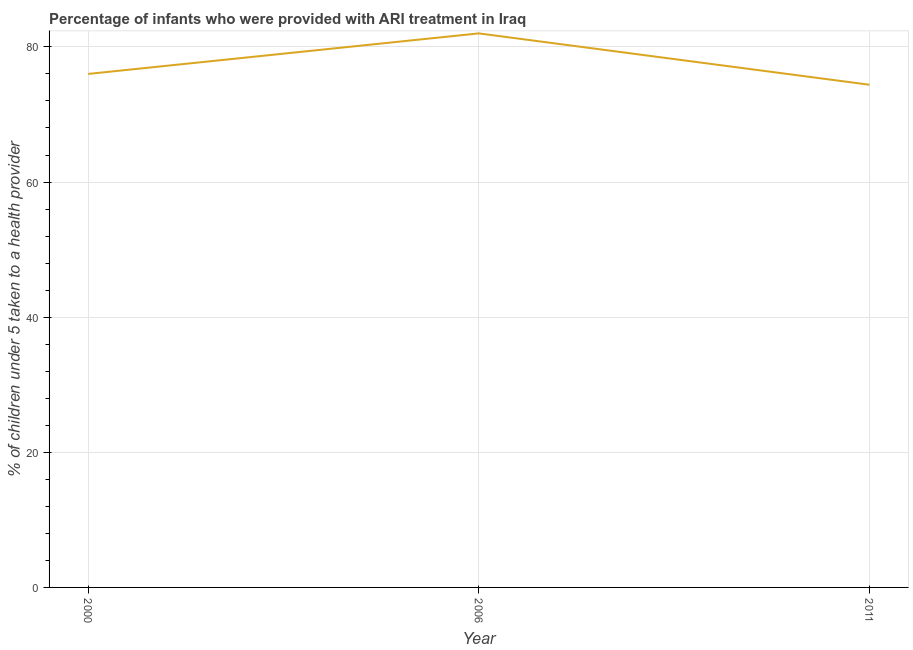What is the percentage of children who were provided with ari treatment in 2000?
Make the answer very short. 76. Across all years, what is the maximum percentage of children who were provided with ari treatment?
Give a very brief answer. 82. Across all years, what is the minimum percentage of children who were provided with ari treatment?
Offer a very short reply. 74.4. In which year was the percentage of children who were provided with ari treatment maximum?
Offer a very short reply. 2006. What is the sum of the percentage of children who were provided with ari treatment?
Keep it short and to the point. 232.4. What is the difference between the percentage of children who were provided with ari treatment in 2006 and 2011?
Offer a very short reply. 7.6. What is the average percentage of children who were provided with ari treatment per year?
Your answer should be compact. 77.47. In how many years, is the percentage of children who were provided with ari treatment greater than 24 %?
Your answer should be compact. 3. What is the ratio of the percentage of children who were provided with ari treatment in 2000 to that in 2011?
Make the answer very short. 1.02. Is the percentage of children who were provided with ari treatment in 2006 less than that in 2011?
Provide a short and direct response. No. Is the difference between the percentage of children who were provided with ari treatment in 2000 and 2006 greater than the difference between any two years?
Your answer should be compact. No. What is the difference between the highest and the lowest percentage of children who were provided with ari treatment?
Your answer should be very brief. 7.6. In how many years, is the percentage of children who were provided with ari treatment greater than the average percentage of children who were provided with ari treatment taken over all years?
Ensure brevity in your answer.  1. How many years are there in the graph?
Offer a terse response. 3. Does the graph contain any zero values?
Provide a short and direct response. No. Does the graph contain grids?
Make the answer very short. Yes. What is the title of the graph?
Give a very brief answer. Percentage of infants who were provided with ARI treatment in Iraq. What is the label or title of the X-axis?
Provide a short and direct response. Year. What is the label or title of the Y-axis?
Your answer should be very brief. % of children under 5 taken to a health provider. What is the % of children under 5 taken to a health provider in 2006?
Provide a succinct answer. 82. What is the % of children under 5 taken to a health provider of 2011?
Offer a very short reply. 74.4. What is the difference between the % of children under 5 taken to a health provider in 2000 and 2011?
Your answer should be very brief. 1.6. What is the ratio of the % of children under 5 taken to a health provider in 2000 to that in 2006?
Offer a terse response. 0.93. What is the ratio of the % of children under 5 taken to a health provider in 2000 to that in 2011?
Your answer should be very brief. 1.02. What is the ratio of the % of children under 5 taken to a health provider in 2006 to that in 2011?
Your answer should be very brief. 1.1. 